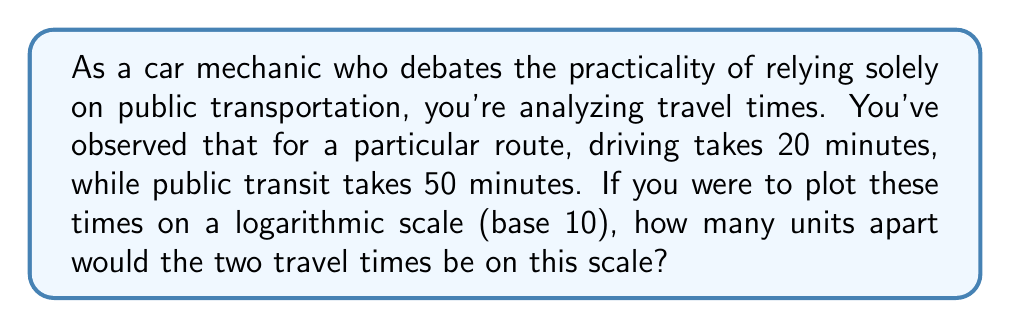Show me your answer to this math problem. To solve this problem, we need to follow these steps:

1) First, let's recall that on a logarithmic scale, the position of a value is determined by the logarithm of that value.

2) We need to calculate the logarithm (base 10) of both travel times:

   For driving: $\log_{10}(20) = 1.301$
   For public transit: $\log_{10}(50) = 1.699$

3) The distance between these two points on the logarithmic scale is the absolute difference between these logarithms:

   $|\log_{10}(50) - \log_{10}(20)| = |1.699 - 1.301| = 0.398$

4) We can simplify this calculation using the properties of logarithms:

   $\log_{10}(50) - \log_{10}(20) = \log_{10}(\frac{50}{20}) = \log_{10}(2.5) = 0.398$

5) This result means that on a logarithmic scale (base 10), the public transit time would be plotted 0.398 units to the right of the driving time.

This logarithmic representation allows us to compare relative differences rather than absolute differences, which can be useful when dealing with a wide range of travel times across different routes or modes of transportation.
Answer: The two travel times would be 0.398 units apart on a logarithmic scale (base 10). 